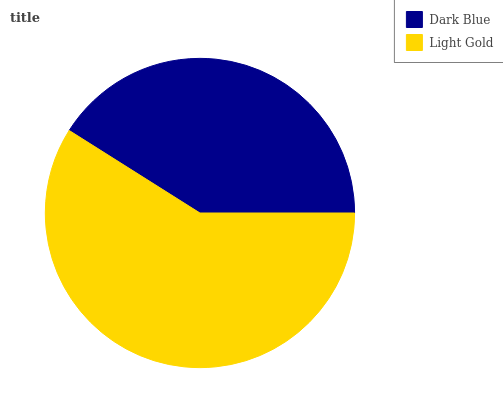Is Dark Blue the minimum?
Answer yes or no. Yes. Is Light Gold the maximum?
Answer yes or no. Yes. Is Light Gold the minimum?
Answer yes or no. No. Is Light Gold greater than Dark Blue?
Answer yes or no. Yes. Is Dark Blue less than Light Gold?
Answer yes or no. Yes. Is Dark Blue greater than Light Gold?
Answer yes or no. No. Is Light Gold less than Dark Blue?
Answer yes or no. No. Is Light Gold the high median?
Answer yes or no. Yes. Is Dark Blue the low median?
Answer yes or no. Yes. Is Dark Blue the high median?
Answer yes or no. No. Is Light Gold the low median?
Answer yes or no. No. 